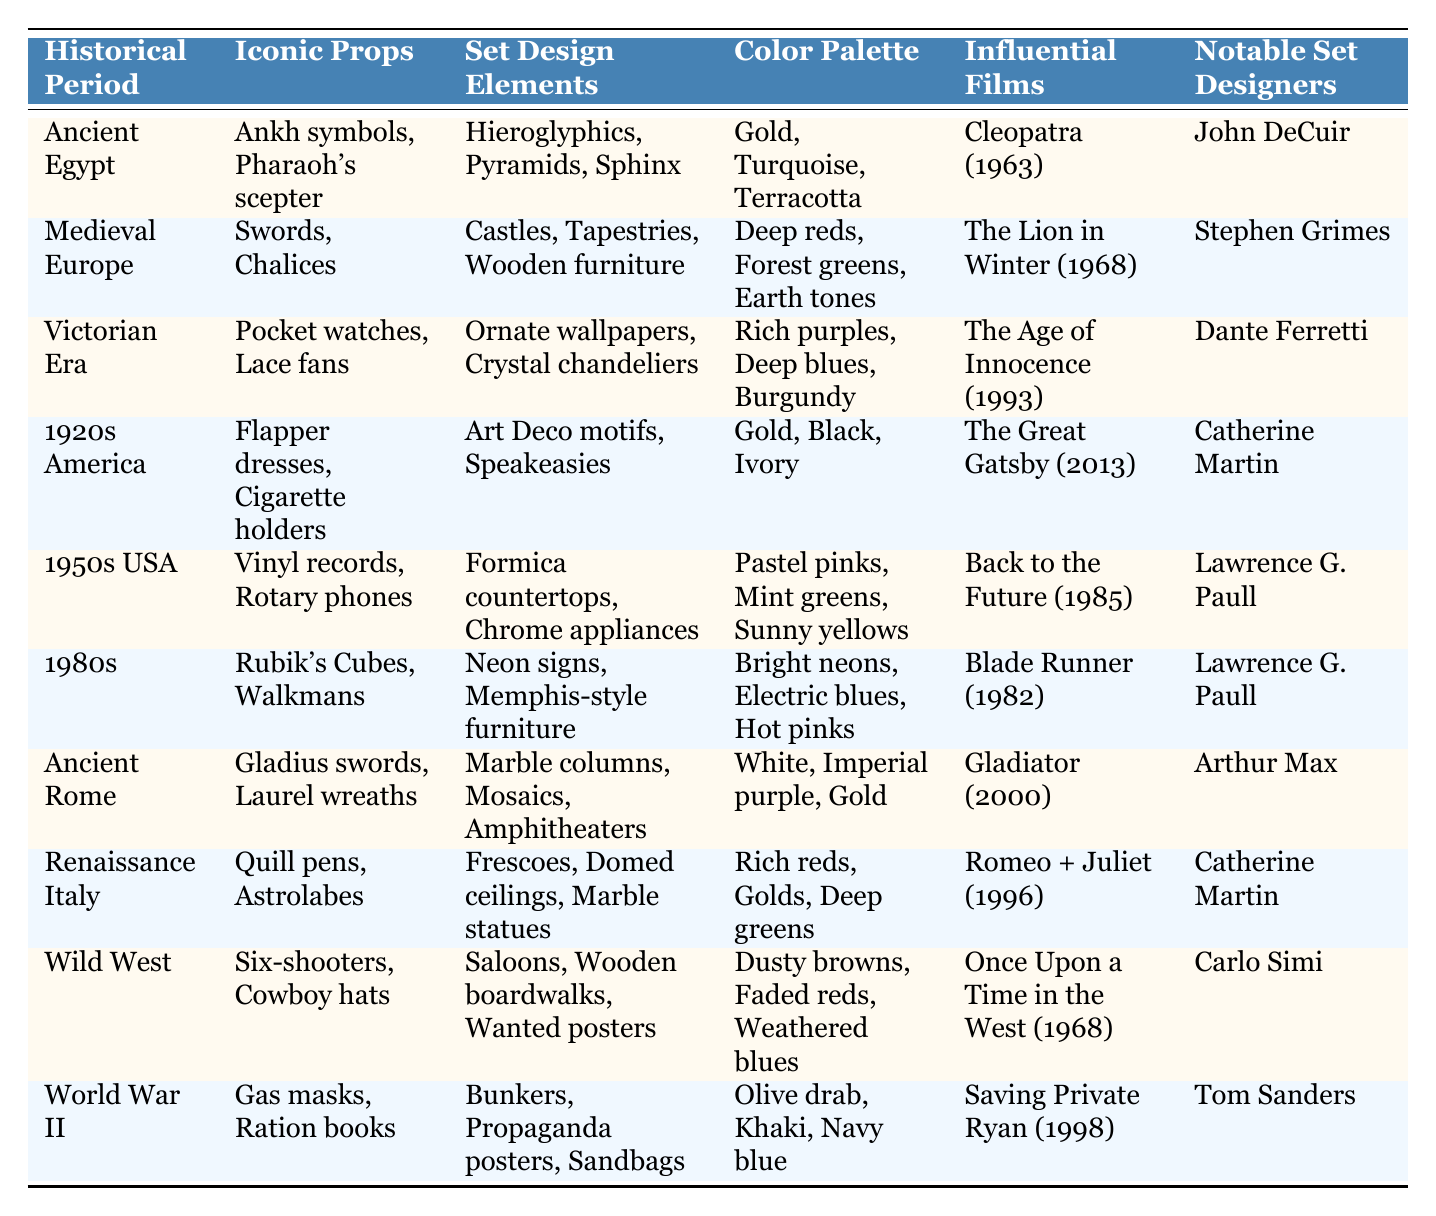What iconic prop is associated with the Renaissance Italy period? The table lists "Quill pens, Astrolabes" as the iconic props for the Renaissance Italy period.
Answer: Quill pens, Astrolabes Which historical period features the color palette of deep reds, forest greens, and earth tones? The table indicates that the Medieval Europe period has the color palette of deep reds, forest greens, and earth tones.
Answer: Medieval Europe Are vinyl records mentioned as a prop in any other historical period besides the 1950s USA? The table only mentions vinyl records in the context of the 1950s USA and does not list them under any other historical period.
Answer: No What are the influential films listed for Ancient Rome and Ancient Egypt? The influential film for Ancient Rome is "Gladiator (2000)" and for Ancient Egypt it is "Cleopatra (1963)".
Answer: Gladiator (2000), Cleopatra (1963) Which historical period is associated with notable set designer Dante Ferretti? The table shows that Dante Ferretti is associated with the Victorian Era.
Answer: Victorian Era How many historical periods included props related to warfare, and what are they? The table lists Ancient Egypt (Pharaoh's scepter), Medieval Europe (Swords), Ancient Rome (Gladius swords), Wild West (Six-shooters), and World War II (Gas masks). That's a total of five periods.
Answer: Five periods: Ancient Egypt, Medieval Europe, Ancient Rome, Wild West, World War II Identify the two color palettes associated with 1980s and 1920s America. According to the table, the 1980s color palette is "Bright neons, Electric blues, Hot pinks," while 1920s America's is "Gold, Black, Ivory."
Answer: 1980s: Bright neons, Electric blues, Hot pinks; 1920s America: Gold, Black, Ivory Which set design element appears in both Ancient Rome and Renaissance Italy? The table shows that both historical periods feature "Marble" as a set design element; Ancient Rome includes "Marble columns" and Renaissance Italy mentions "Marble statues."
Answer: Marble What is the difference in the color palettes between the Victorian Era and the World War II period? The color palette for the Victorian Era is "Rich purples, Deep blues, Burgundy," while for World War II, it is "Olive drab, Khaki, Navy blue." The difference is evident in their color schemes focusing on opulence versus military tones.
Answer: Different tones and themes Which notable set designer collaborated on films set in different historical periods? The table indicates that Catherine Martin worked on films from both the 1920s America ("The Great Gatsby") and Renaissance Italy ("Romeo + Juliet").
Answer: Catherine Martin 